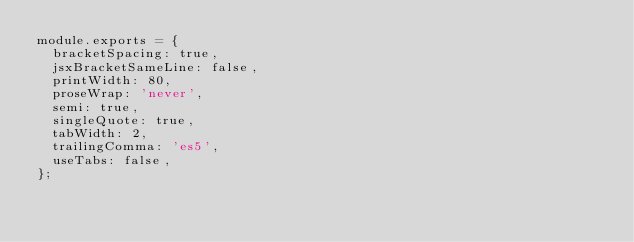Convert code to text. <code><loc_0><loc_0><loc_500><loc_500><_JavaScript_>module.exports = {
  bracketSpacing: true,
  jsxBracketSameLine: false,
  printWidth: 80,
  proseWrap: 'never',
  semi: true,
  singleQuote: true,
  tabWidth: 2,
  trailingComma: 'es5',
  useTabs: false,
};</code> 